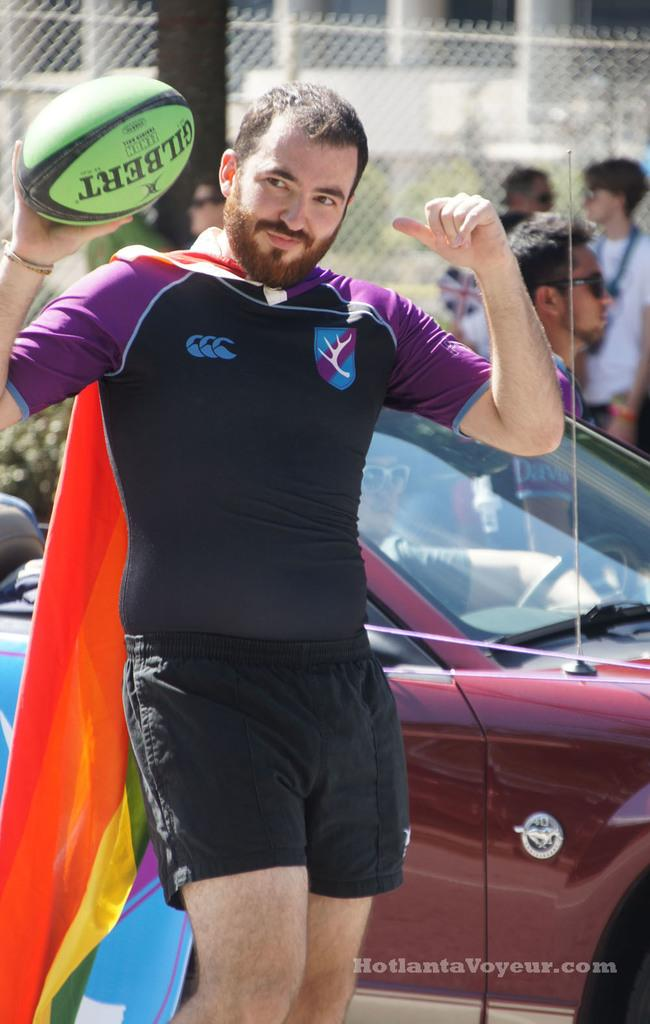What is the man in the image doing? The man is standing in the image and holding a ball in his hand. What can be seen in the background of the image? There is a car, a group of people, and a tree in the background of the image. What type of board is the judge using to make a decision in the image? There is no judge or board present in the image. 